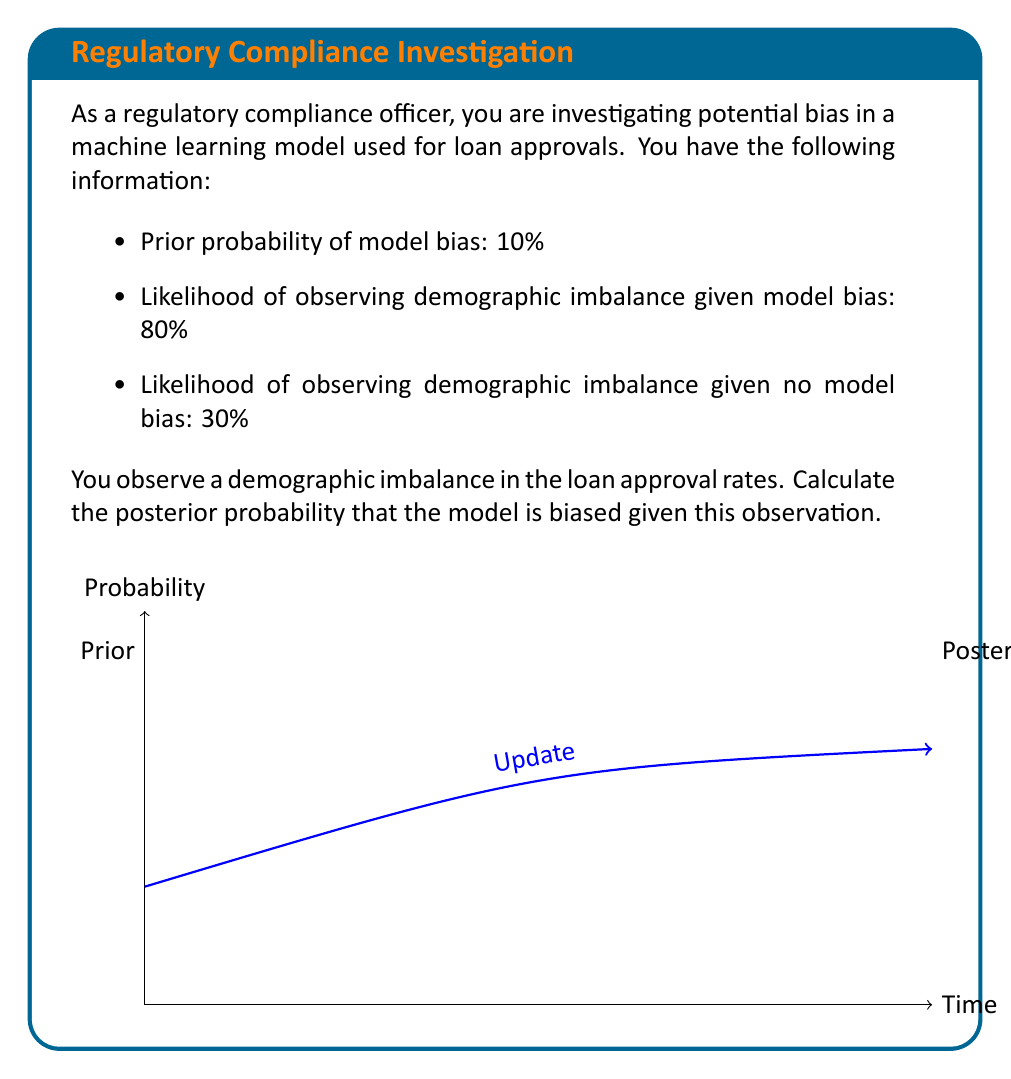Could you help me with this problem? To solve this problem, we'll use Bayes' theorem:

$$P(B|D) = \frac{P(D|B) \cdot P(B)}{P(D)}$$

Where:
- $B$ represents model bias
- $D$ represents demographic imbalance
- $P(B|D)$ is the posterior probability of model bias given demographic imbalance
- $P(D|B)$ is the likelihood of observing demographic imbalance given model bias
- $P(B)$ is the prior probability of model bias
- $P(D)$ is the total probability of observing demographic imbalance

Step 1: Identify the given probabilities
- $P(B) = 0.10$ (prior probability of model bias)
- $P(D|B) = 0.80$ (likelihood of demographic imbalance given bias)
- $P(D|\neg B) = 0.30$ (likelihood of demographic imbalance given no bias)

Step 2: Calculate $P(D)$ using the law of total probability
$$P(D) = P(D|B) \cdot P(B) + P(D|\neg B) \cdot P(\neg B)$$
$$P(D) = 0.80 \cdot 0.10 + 0.30 \cdot 0.90 = 0.08 + 0.27 = 0.35$$

Step 3: Apply Bayes' theorem
$$P(B|D) = \frac{P(D|B) \cdot P(B)}{P(D)} = \frac{0.80 \cdot 0.10}{0.35} = \frac{0.08}{0.35} \approx 0.2286$$

Step 4: Convert to percentage
$$P(B|D) \approx 0.2286 \cdot 100\% = 22.86\%$$

Therefore, the posterior probability that the model is biased given the observed demographic imbalance is approximately 22.86%.
Answer: 22.86% 